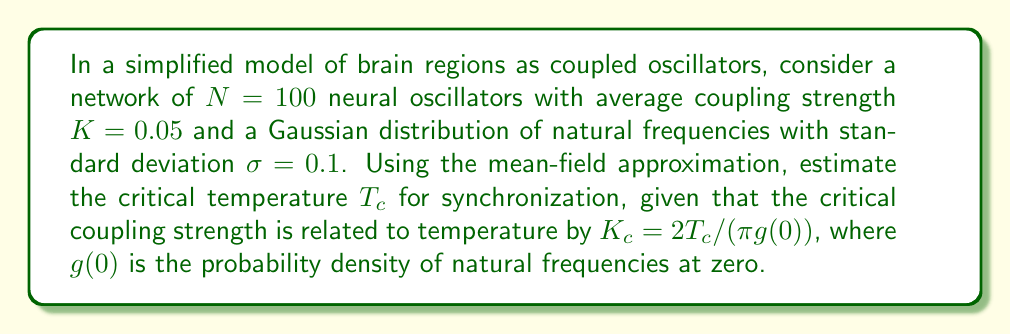Solve this math problem. 1) In the mean-field approximation for coupled oscillators, the critical coupling strength $K_c$ is related to the probability density of natural frequencies at zero, $g(0)$, by:

   $$K_c = \frac{2}{\pi g(0)}$$

2) For a Gaussian distribution with standard deviation $\sigma$, the probability density at zero is:

   $$g(0) = \frac{1}{\sigma\sqrt{2\pi}}$$

3) Substituting the given $\sigma = 0.1$:

   $$g(0) = \frac{1}{0.1\sqrt{2\pi}} \approx 3.989$$

4) Now, we can relate the critical coupling strength to temperature:

   $$K_c = \frac{2T_c}{\pi g(0)}$$

5) Rearranging to solve for $T_c$:

   $$T_c = \frac{\pi g(0) K_c}{2}$$

6) We're given the actual coupling strength $K = 0.05$. At the critical temperature, this should equal $K_c$. Substituting:

   $$T_c = \frac{\pi \cdot 3.989 \cdot 0.05}{2} \approx 0.313$$

Therefore, the estimated critical temperature for synchronization is approximately 0.313 in the units of the system.
Answer: $T_c \approx 0.313$ 